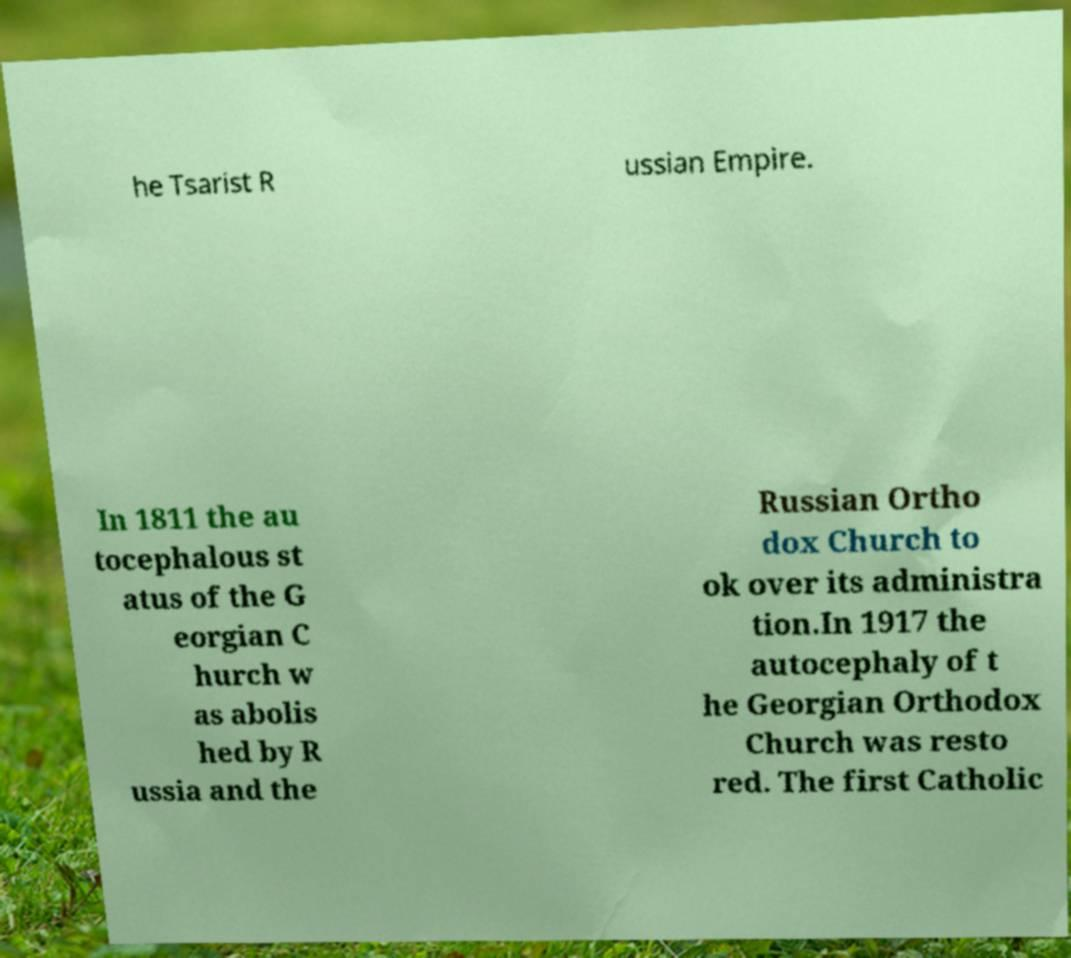There's text embedded in this image that I need extracted. Can you transcribe it verbatim? he Tsarist R ussian Empire. In 1811 the au tocephalous st atus of the G eorgian C hurch w as abolis hed by R ussia and the Russian Ortho dox Church to ok over its administra tion.In 1917 the autocephaly of t he Georgian Orthodox Church was resto red. The first Catholic 